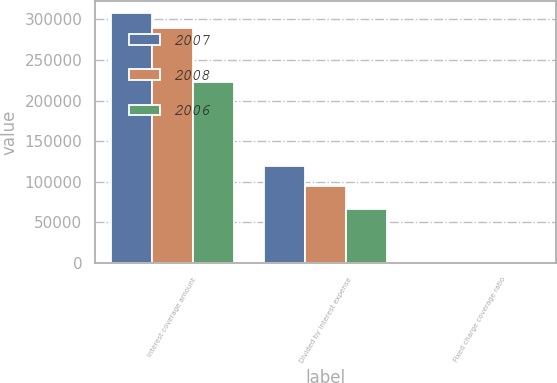Convert chart to OTSL. <chart><loc_0><loc_0><loc_500><loc_500><stacked_bar_chart><ecel><fcel>Interest coverage amount<fcel>Divided by interest expense<fcel>Fixed charge coverage ratio<nl><fcel>2007<fcel>307304<fcel>120006<fcel>2.6<nl><fcel>2008<fcel>289413<fcel>94785<fcel>3.1<nl><fcel>2006<fcel>223139<fcel>66433<fcel>3.4<nl></chart> 